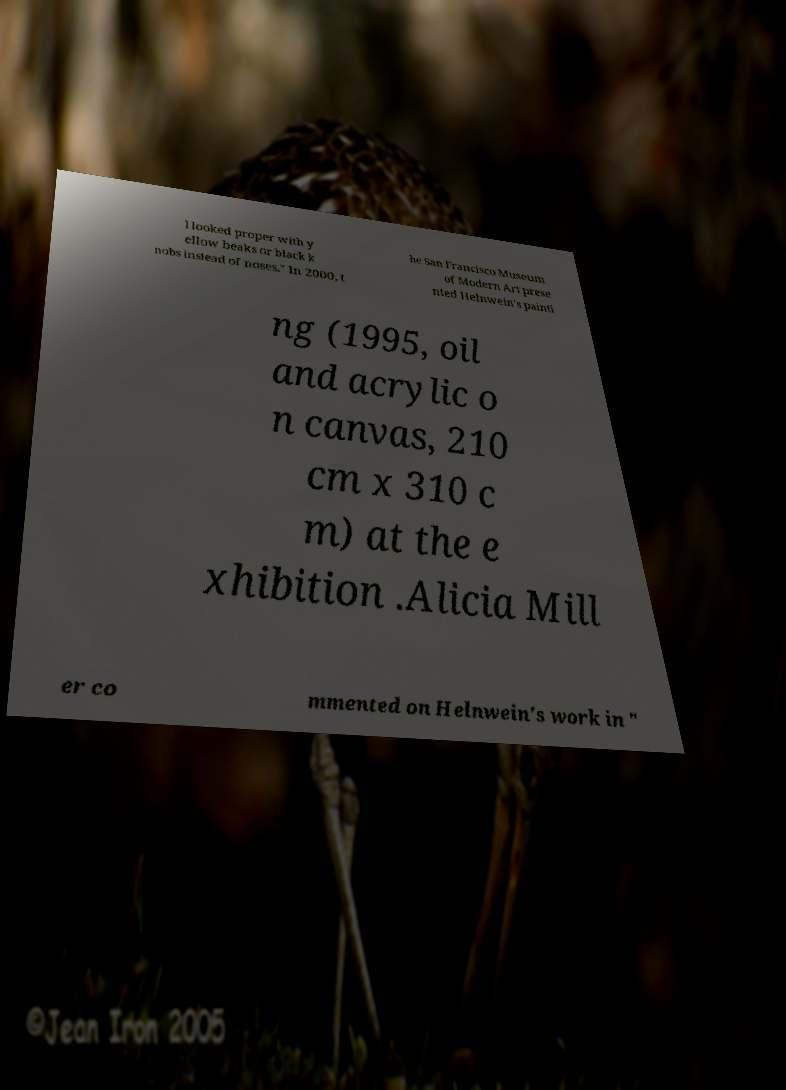Could you assist in decoding the text presented in this image and type it out clearly? l looked proper with y ellow beaks or black k nobs instead of noses." In 2000, t he San Francisco Museum of Modern Art prese nted Helnwein's painti ng (1995, oil and acrylic o n canvas, 210 cm x 310 c m) at the e xhibition .Alicia Mill er co mmented on Helnwein's work in " 